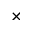Convert formula to latex. <formula><loc_0><loc_0><loc_500><loc_500>\times</formula> 